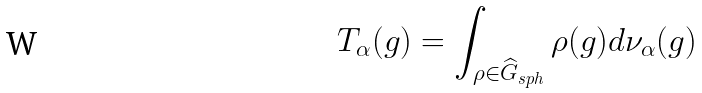<formula> <loc_0><loc_0><loc_500><loc_500>T _ { \alpha } ( g ) = \int _ { \rho \in \widehat { G } _ { s p h } } \rho ( g ) d \nu _ { \alpha } ( g )</formula> 